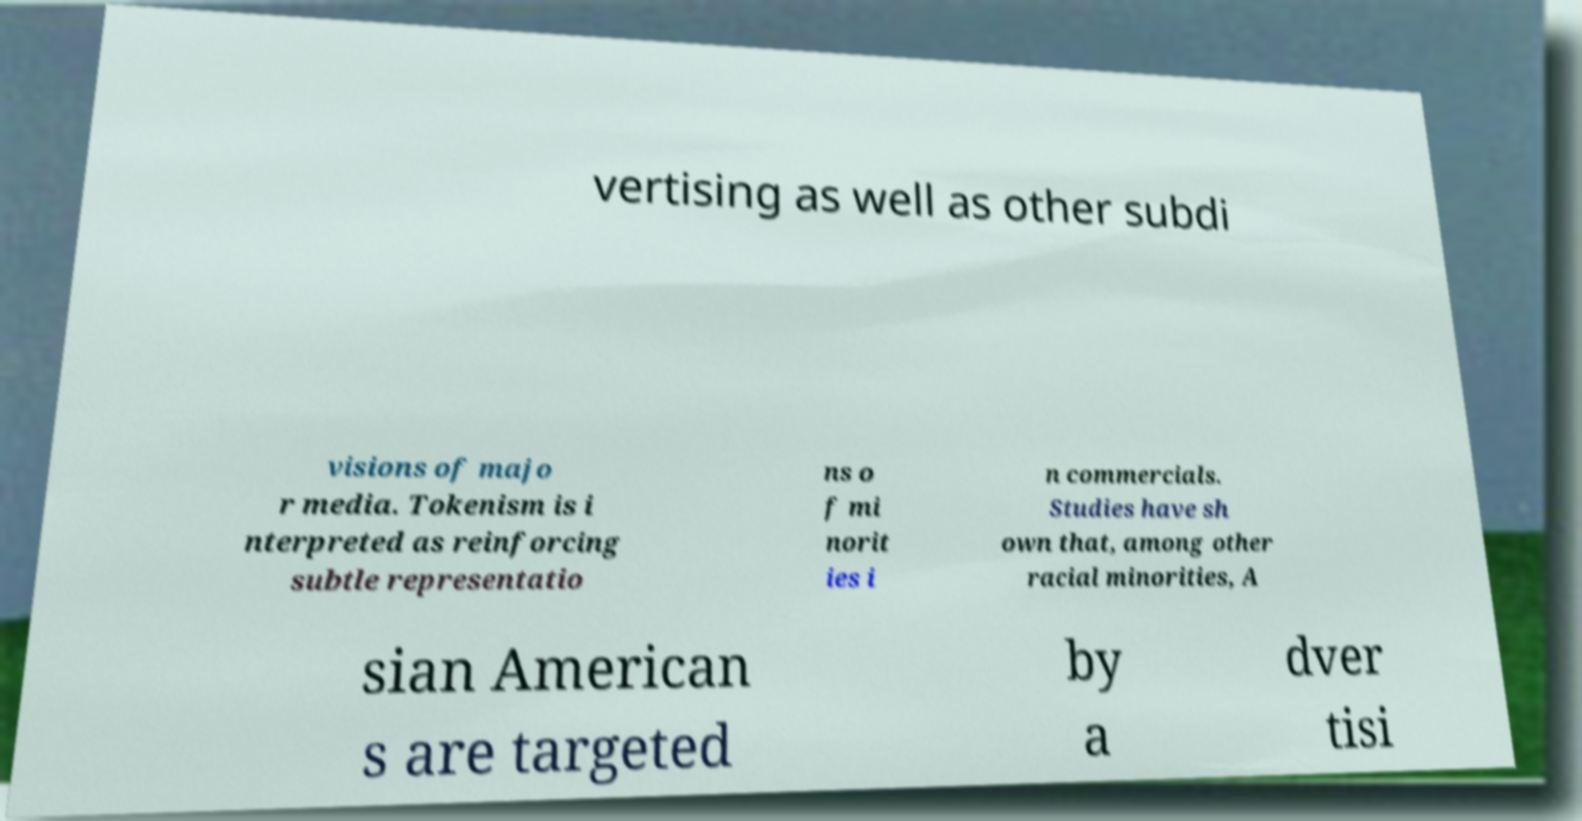What is the topic discussed in this image? The text in the image appears to discuss the role of tokenism within advertising, with a particular focus on racial minorities and how they are represented in media. 